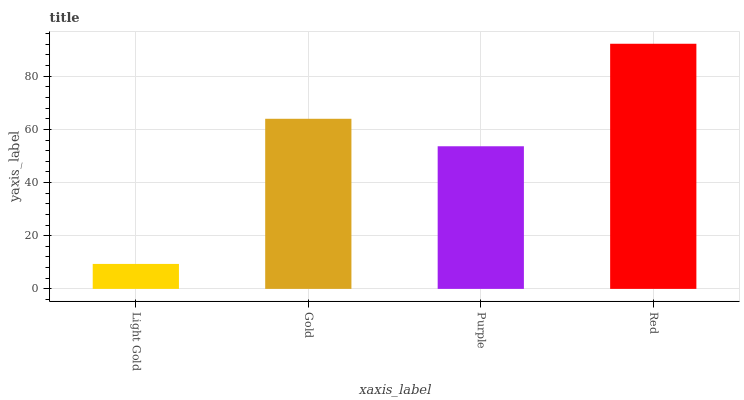Is Light Gold the minimum?
Answer yes or no. Yes. Is Red the maximum?
Answer yes or no. Yes. Is Gold the minimum?
Answer yes or no. No. Is Gold the maximum?
Answer yes or no. No. Is Gold greater than Light Gold?
Answer yes or no. Yes. Is Light Gold less than Gold?
Answer yes or no. Yes. Is Light Gold greater than Gold?
Answer yes or no. No. Is Gold less than Light Gold?
Answer yes or no. No. Is Gold the high median?
Answer yes or no. Yes. Is Purple the low median?
Answer yes or no. Yes. Is Purple the high median?
Answer yes or no. No. Is Gold the low median?
Answer yes or no. No. 